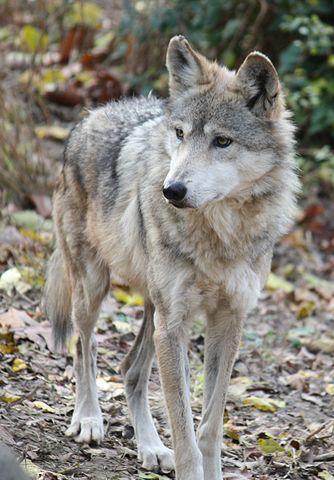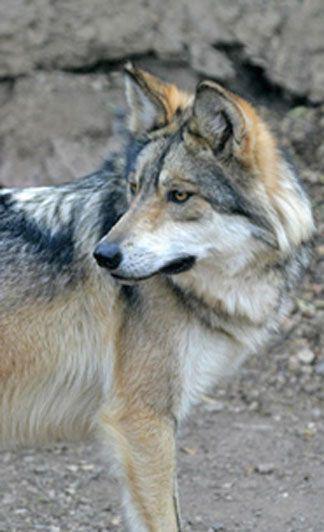The first image is the image on the left, the second image is the image on the right. Analyze the images presented: Is the assertion "wolves are facing oposite directions in the image pair" valid? Answer yes or no. No. The first image is the image on the left, the second image is the image on the right. Considering the images on both sides, is "in both photos the wolf is facing the same direction" valid? Answer yes or no. Yes. 